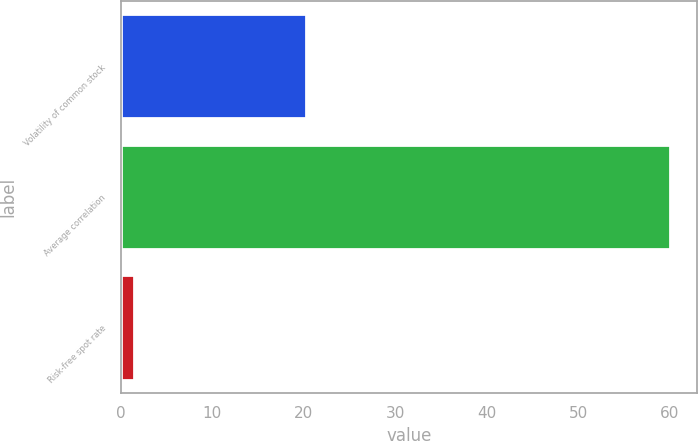Convert chart to OTSL. <chart><loc_0><loc_0><loc_500><loc_500><bar_chart><fcel>Volatility of common stock<fcel>Average correlation<fcel>Risk-free spot rate<nl><fcel>20.3<fcel>60<fcel>1.5<nl></chart> 